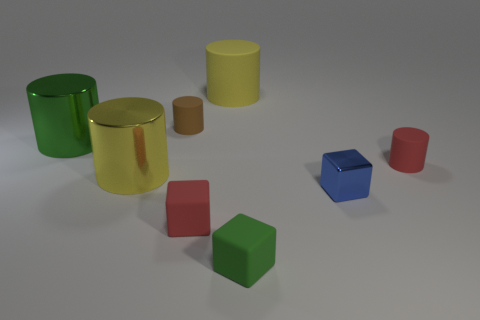Subtract all yellow cylinders. How many were subtracted if there are1yellow cylinders left? 1 Subtract 2 cylinders. How many cylinders are left? 3 Subtract all red cylinders. How many cylinders are left? 4 Subtract all big green shiny cylinders. How many cylinders are left? 4 Subtract all green cylinders. Subtract all cyan spheres. How many cylinders are left? 4 Add 2 purple rubber blocks. How many objects exist? 10 Subtract all cubes. How many objects are left? 5 Add 2 small cylinders. How many small cylinders are left? 4 Add 6 yellow metal things. How many yellow metal things exist? 7 Subtract 1 blue cubes. How many objects are left? 7 